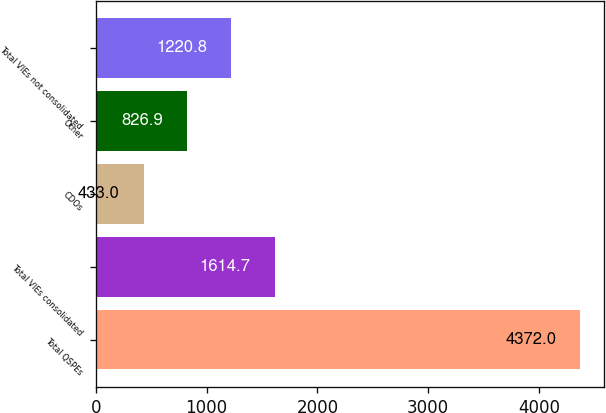Convert chart. <chart><loc_0><loc_0><loc_500><loc_500><bar_chart><fcel>Total QSPEs<fcel>Total VIEs consolidated<fcel>CDOs<fcel>Other<fcel>Total VIEs not consolidated<nl><fcel>4372<fcel>1614.7<fcel>433<fcel>826.9<fcel>1220.8<nl></chart> 